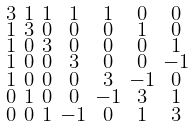<formula> <loc_0><loc_0><loc_500><loc_500>\begin{smallmatrix} 3 & 1 & 1 & 1 & 1 & 0 & 0 \\ 1 & 3 & 0 & 0 & 0 & 1 & 0 \\ 1 & 0 & 3 & 0 & 0 & 0 & 1 \\ 1 & 0 & 0 & 3 & 0 & 0 & - 1 \\ 1 & 0 & 0 & 0 & 3 & - 1 & 0 \\ 0 & 1 & 0 & 0 & - 1 & 3 & 1 \\ 0 & 0 & 1 & - 1 & 0 & 1 & 3 \end{smallmatrix}</formula> 